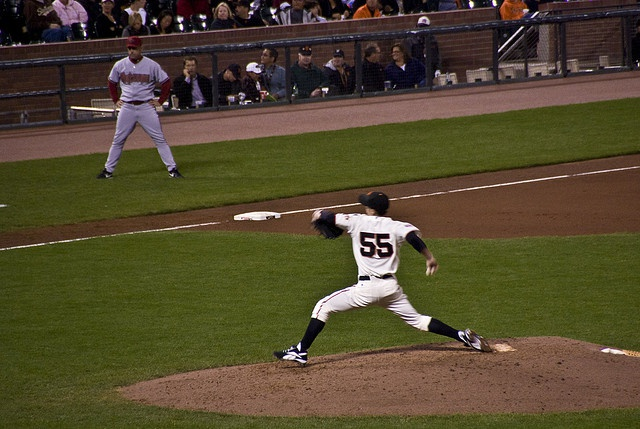Describe the objects in this image and their specific colors. I can see people in black, maroon, gray, and darkgray tones, people in black, lightgray, darkgreen, and darkgray tones, people in black and gray tones, people in black, maroon, and gray tones, and people in black, gray, maroon, and purple tones in this image. 